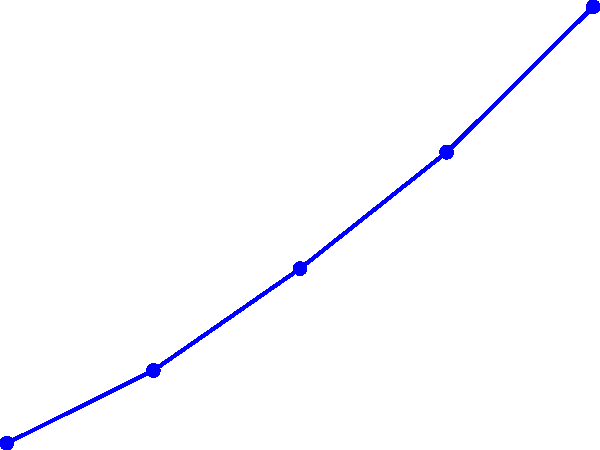Based on the line graph showing projected population growth in areas surrounding nuclear power plants, what is the estimated population increase from 2020 to 2040? To find the population increase from 2020 to 2040:

1. Identify the population in 2020: 100,000
2. Identify the population in 2040: 130,000
3. Calculate the difference:
   $130,000 - 100,000 = 30,000$

The population is projected to increase by 30,000 people over the 20-year period.

To calculate the percentage increase:
4. Use the formula: $\text{Percentage increase} = \frac{\text{Increase}}{\text{Original Value}} \times 100$
5. Plug in the values: $\frac{30,000}{100,000} \times 100 = 30\%$

Therefore, the population is projected to increase by 30,000 people or 30% from 2020 to 2040.
Answer: 30,000 people (30% increase) 